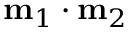Convert formula to latex. <formula><loc_0><loc_0><loc_500><loc_500>m _ { 1 } \cdot m _ { 2 }</formula> 